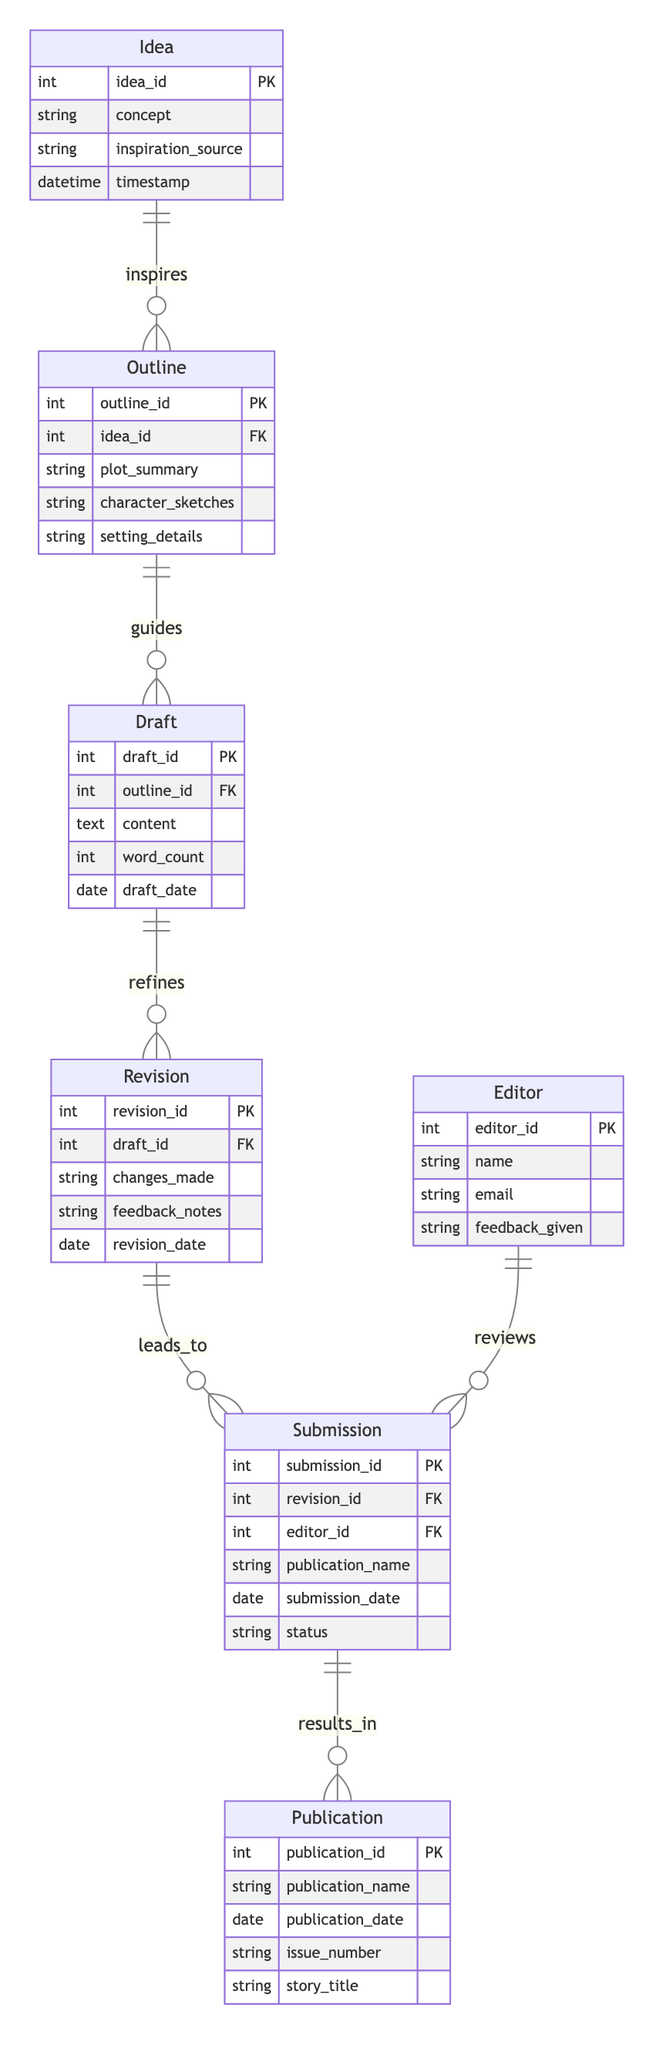What entities are present in the diagram? The diagram includes the following entities: Idea, Outline, Draft, Revision, Editor, Submission, and Publication.
Answer: Idea, Outline, Draft, Revision, Editor, Submission, Publication How many relationships are there in the diagram? The diagram contains six relationships that describe interactions between the entities, indicating how they connect.
Answer: Six What type of relationship exists between Outline and Draft? The relationship between Outline and Draft is characterized as one-to-many, indicating that one Outline can guide multiple Drafts.
Answer: One to many Which entity comes after Draft in the process? Following Draft in the sequence is the Revision entity, which refines the content of the Draft.
Answer: Revision What is the primary key of the Submission entity? The Submission entity has a primary key named submission_id, which uniquely identifies each submission instance.
Answer: submission_id How many revisions can a Draft have? A Draft can have multiple revisions, but since it is a one-to-many relationship with Revision, there is no specified limit in the diagram itself.
Answer: Multiple Which entity provides feedback for the Submission? The Editor entity is responsible for providing feedback for the Submission through its established relationship in the diagram.
Answer: Editor What leads to a Publication? The Submission entity leads to the Publication, indicating that a submission results in a publication if successful.
Answer: Submission How many attributes are associated with the Idea entity? The Idea entity is associated with four attributes: idea_id, concept, inspiration_source, and timestamp.
Answer: Four What is the nature of the relationship between Revision and Submission? The relationship between Revision and Submission is also one-to-many, meaning each Revision can lead to multiple Submissions based on feedback and changes made.
Answer: One to many 